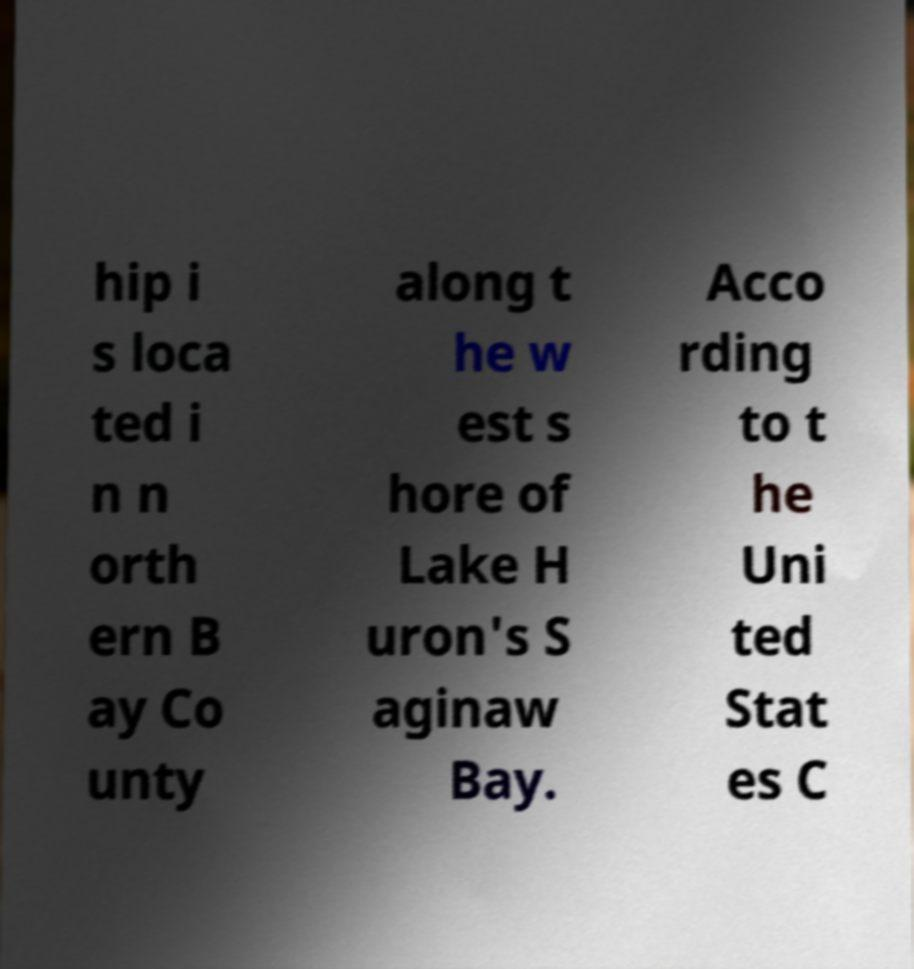Can you accurately transcribe the text from the provided image for me? hip i s loca ted i n n orth ern B ay Co unty along t he w est s hore of Lake H uron's S aginaw Bay. Acco rding to t he Uni ted Stat es C 